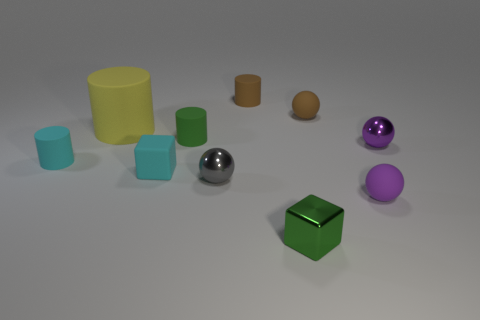Subtract 1 cylinders. How many cylinders are left? 3 Subtract all purple rubber balls. How many balls are left? 3 Subtract all green blocks. How many blocks are left? 1 Subtract all blue spheres. Subtract all yellow cylinders. How many spheres are left? 4 Subtract all blue spheres. How many green cylinders are left? 1 Subtract all small purple matte balls. Subtract all large green metal cylinders. How many objects are left? 9 Add 2 big cylinders. How many big cylinders are left? 3 Add 10 tiny cyan metal cylinders. How many tiny cyan metal cylinders exist? 10 Subtract 0 yellow cubes. How many objects are left? 10 Subtract all cubes. How many objects are left? 8 